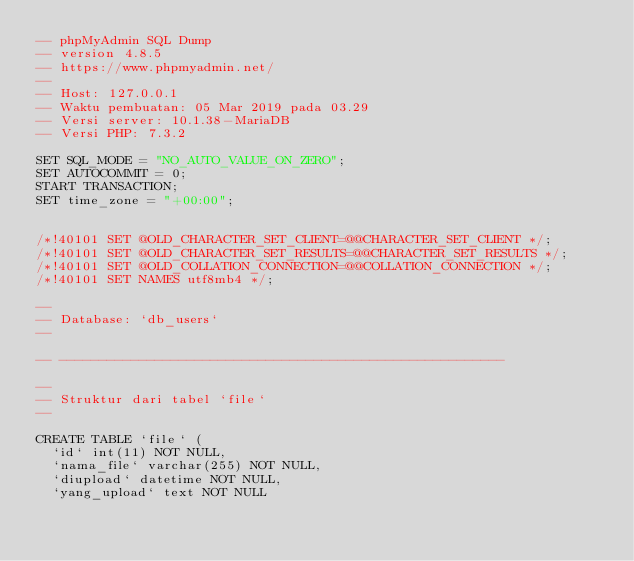<code> <loc_0><loc_0><loc_500><loc_500><_SQL_>-- phpMyAdmin SQL Dump
-- version 4.8.5
-- https://www.phpmyadmin.net/
--
-- Host: 127.0.0.1
-- Waktu pembuatan: 05 Mar 2019 pada 03.29
-- Versi server: 10.1.38-MariaDB
-- Versi PHP: 7.3.2

SET SQL_MODE = "NO_AUTO_VALUE_ON_ZERO";
SET AUTOCOMMIT = 0;
START TRANSACTION;
SET time_zone = "+00:00";


/*!40101 SET @OLD_CHARACTER_SET_CLIENT=@@CHARACTER_SET_CLIENT */;
/*!40101 SET @OLD_CHARACTER_SET_RESULTS=@@CHARACTER_SET_RESULTS */;
/*!40101 SET @OLD_COLLATION_CONNECTION=@@COLLATION_CONNECTION */;
/*!40101 SET NAMES utf8mb4 */;

--
-- Database: `db_users`
--

-- --------------------------------------------------------

--
-- Struktur dari tabel `file`
--

CREATE TABLE `file` (
  `id` int(11) NOT NULL,
  `nama_file` varchar(255) NOT NULL,
  `diupload` datetime NOT NULL,
  `yang_upload` text NOT NULL</code> 